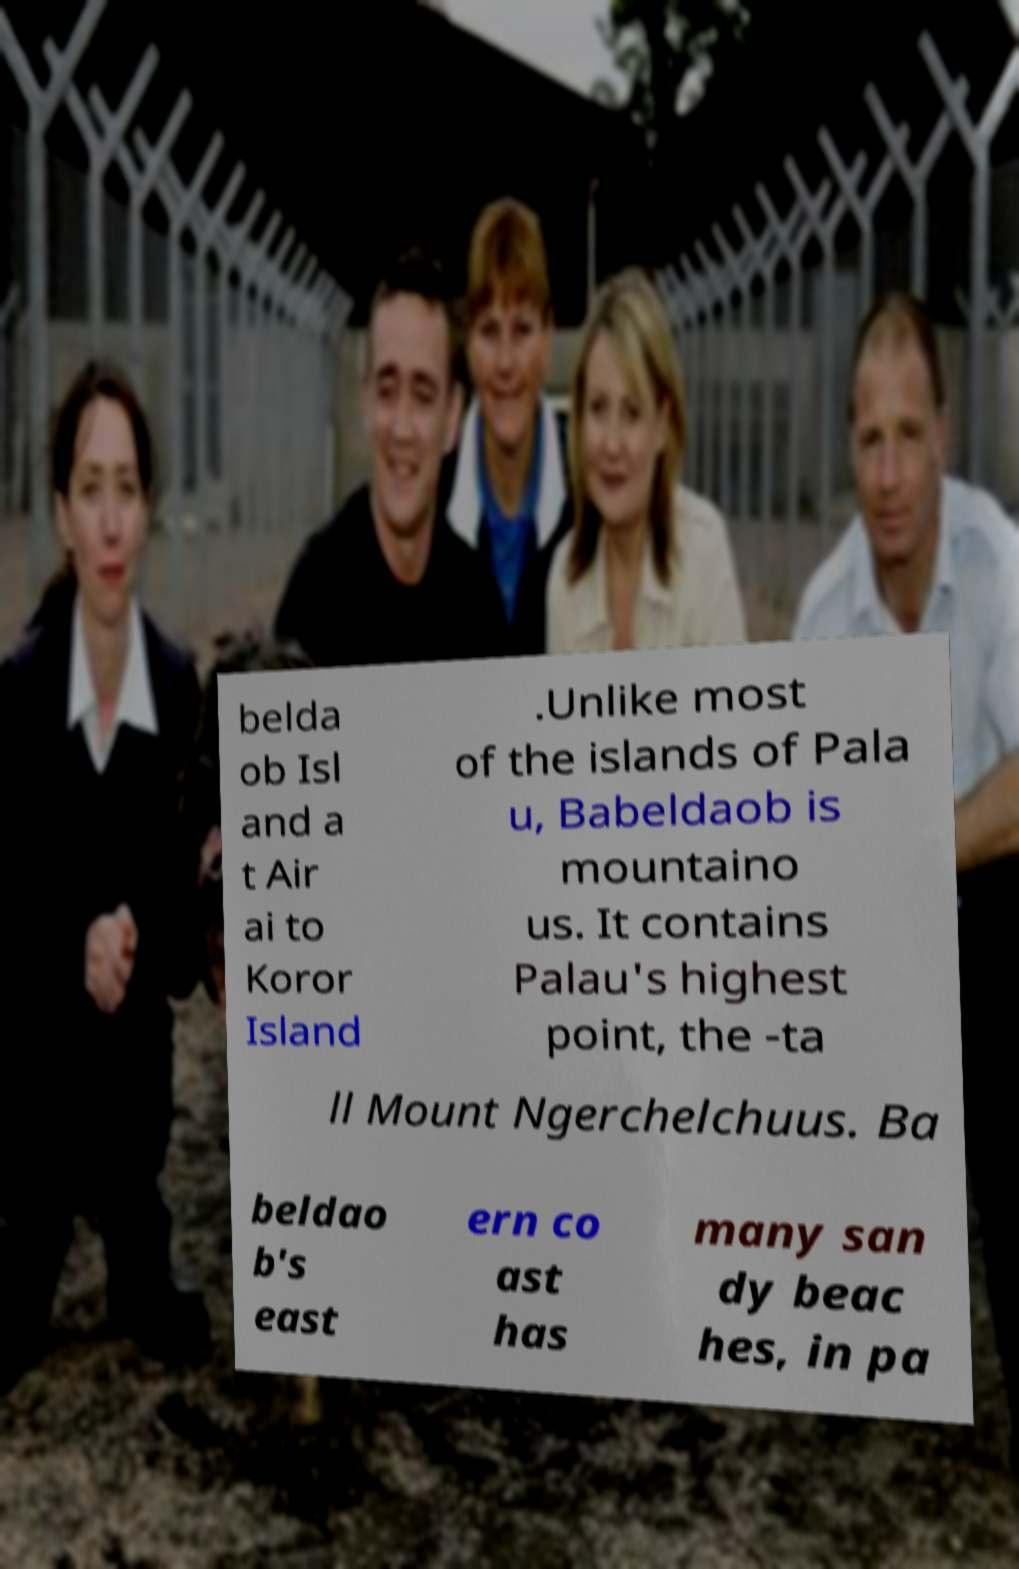There's text embedded in this image that I need extracted. Can you transcribe it verbatim? belda ob Isl and a t Air ai to Koror Island .Unlike most of the islands of Pala u, Babeldaob is mountaino us. It contains Palau's highest point, the -ta ll Mount Ngerchelchuus. Ba beldao b's east ern co ast has many san dy beac hes, in pa 